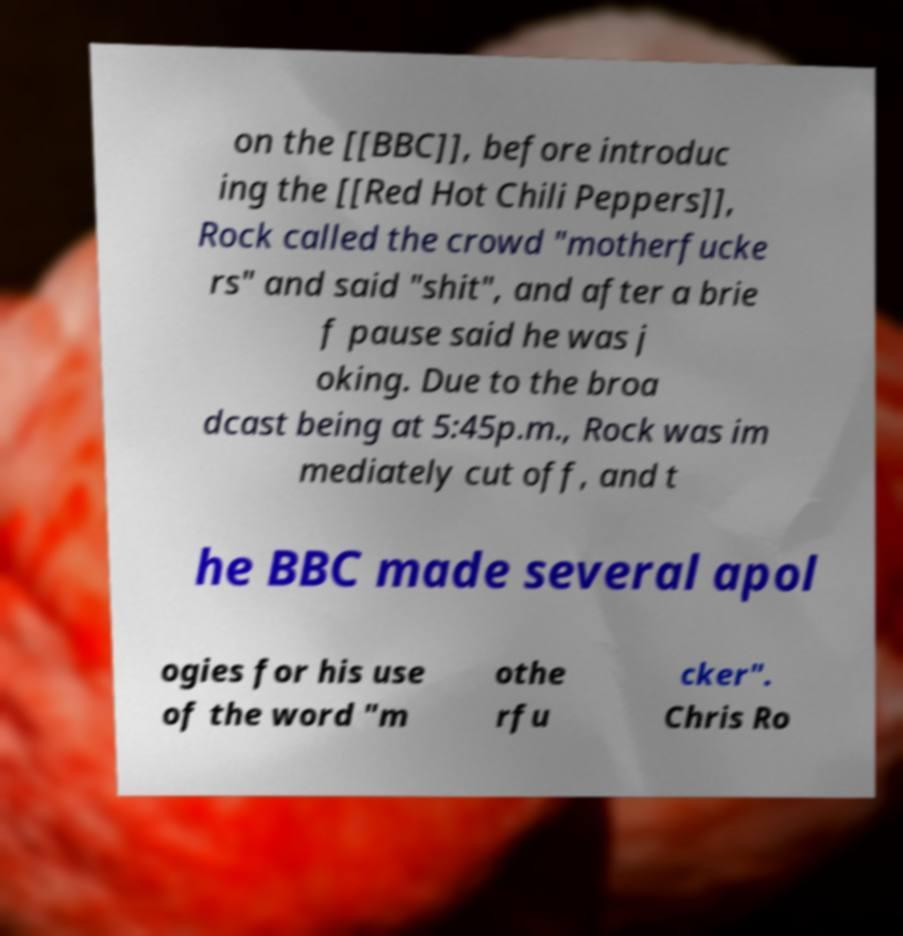There's text embedded in this image that I need extracted. Can you transcribe it verbatim? on the [[BBC]], before introduc ing the [[Red Hot Chili Peppers]], Rock called the crowd "motherfucke rs" and said "shit", and after a brie f pause said he was j oking. Due to the broa dcast being at 5:45p.m., Rock was im mediately cut off, and t he BBC made several apol ogies for his use of the word "m othe rfu cker". Chris Ro 